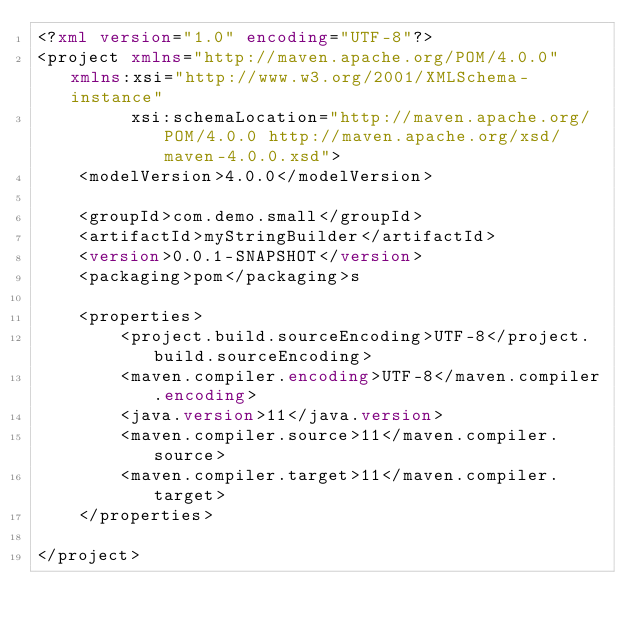<code> <loc_0><loc_0><loc_500><loc_500><_XML_><?xml version="1.0" encoding="UTF-8"?>
<project xmlns="http://maven.apache.org/POM/4.0.0" xmlns:xsi="http://www.w3.org/2001/XMLSchema-instance"
         xsi:schemaLocation="http://maven.apache.org/POM/4.0.0 http://maven.apache.org/xsd/maven-4.0.0.xsd">
    <modelVersion>4.0.0</modelVersion>

    <groupId>com.demo.small</groupId>
    <artifactId>myStringBuilder</artifactId>
    <version>0.0.1-SNAPSHOT</version>
    <packaging>pom</packaging>s

    <properties>
        <project.build.sourceEncoding>UTF-8</project.build.sourceEncoding>
        <maven.compiler.encoding>UTF-8</maven.compiler.encoding>
        <java.version>11</java.version>
        <maven.compiler.source>11</maven.compiler.source>
        <maven.compiler.target>11</maven.compiler.target>
    </properties>

</project></code> 